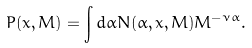Convert formula to latex. <formula><loc_0><loc_0><loc_500><loc_500>P ( x , M ) = \int d \alpha N ( \alpha , x , M ) M ^ { - \nu \alpha } .</formula> 